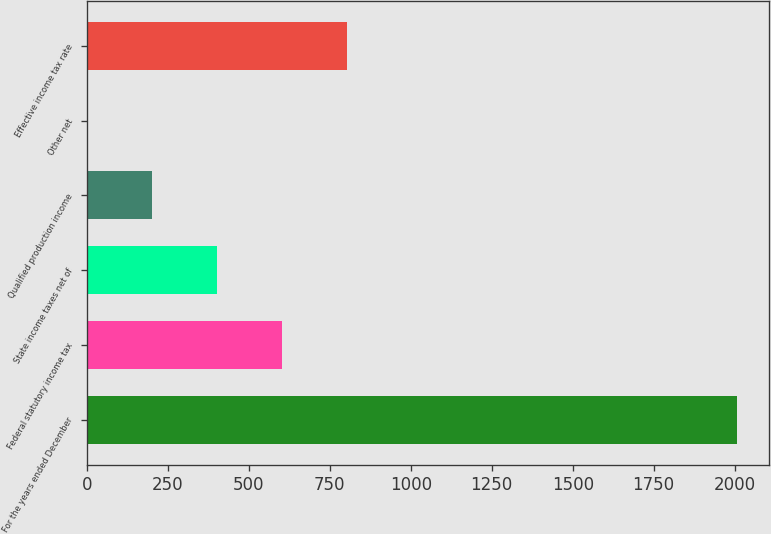<chart> <loc_0><loc_0><loc_500><loc_500><bar_chart><fcel>For the years ended December<fcel>Federal statutory income tax<fcel>State income taxes net of<fcel>Qualified production income<fcel>Other net<fcel>Effective income tax rate<nl><fcel>2007<fcel>602.45<fcel>401.8<fcel>201.15<fcel>0.5<fcel>803.1<nl></chart> 